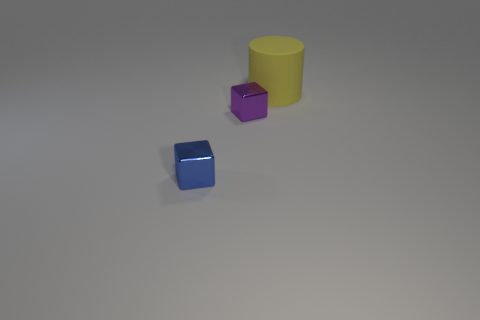Add 2 big rubber cylinders. How many objects exist? 5 Subtract all blocks. How many objects are left? 1 Subtract all big things. Subtract all yellow matte things. How many objects are left? 1 Add 1 purple objects. How many purple objects are left? 2 Add 3 tiny blue metal blocks. How many tiny blue metal blocks exist? 4 Subtract 0 red blocks. How many objects are left? 3 